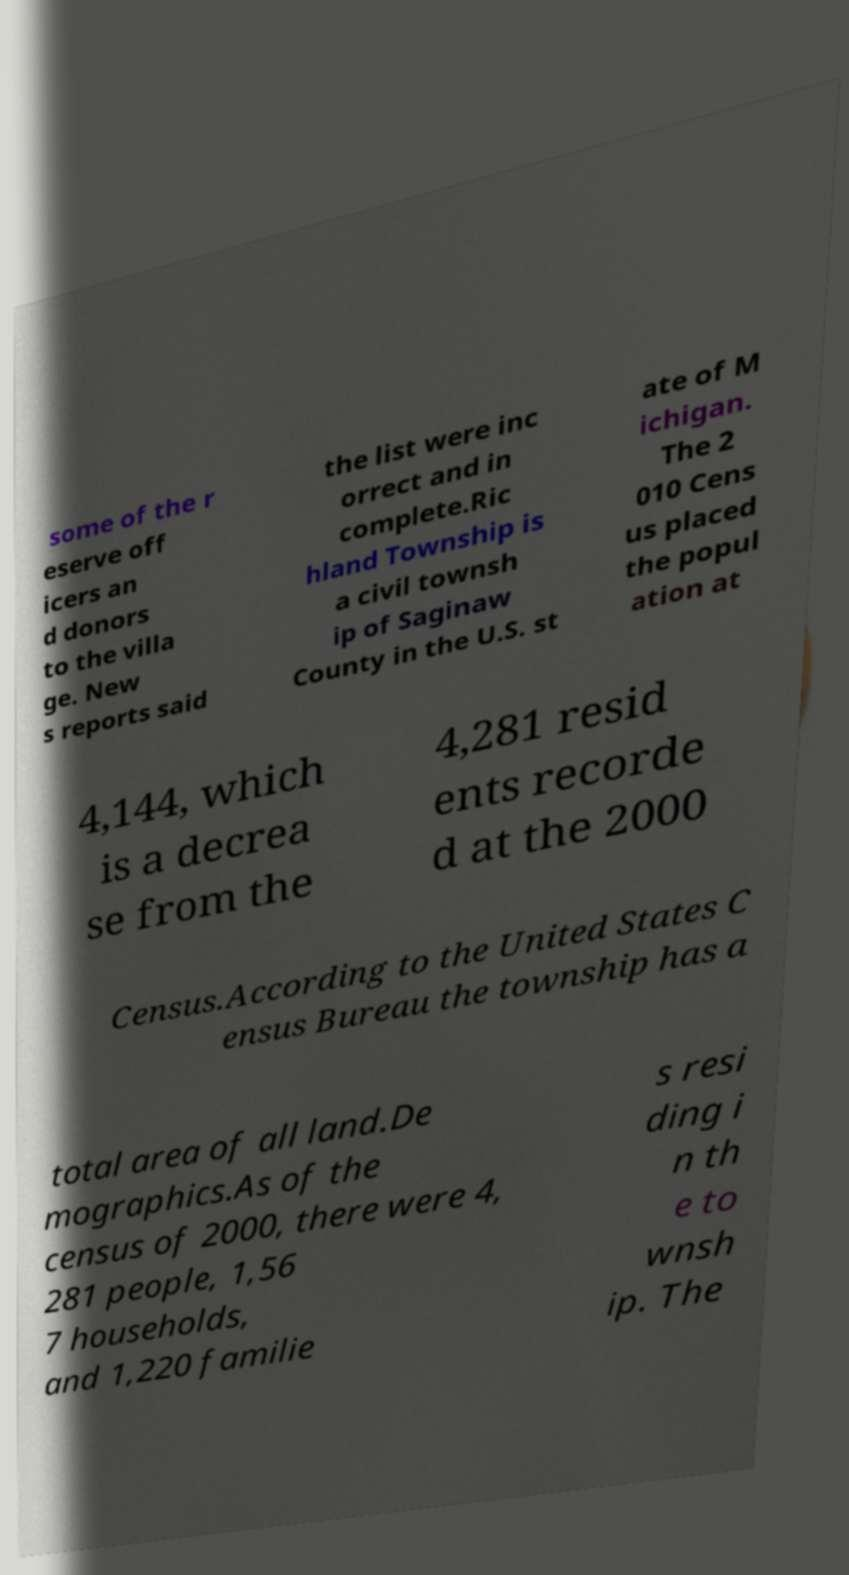Please read and relay the text visible in this image. What does it say? some of the r eserve off icers an d donors to the villa ge. New s reports said the list were inc orrect and in complete.Ric hland Township is a civil townsh ip of Saginaw County in the U.S. st ate of M ichigan. The 2 010 Cens us placed the popul ation at 4,144, which is a decrea se from the 4,281 resid ents recorde d at the 2000 Census.According to the United States C ensus Bureau the township has a total area of all land.De mographics.As of the census of 2000, there were 4, 281 people, 1,56 7 households, and 1,220 familie s resi ding i n th e to wnsh ip. The 